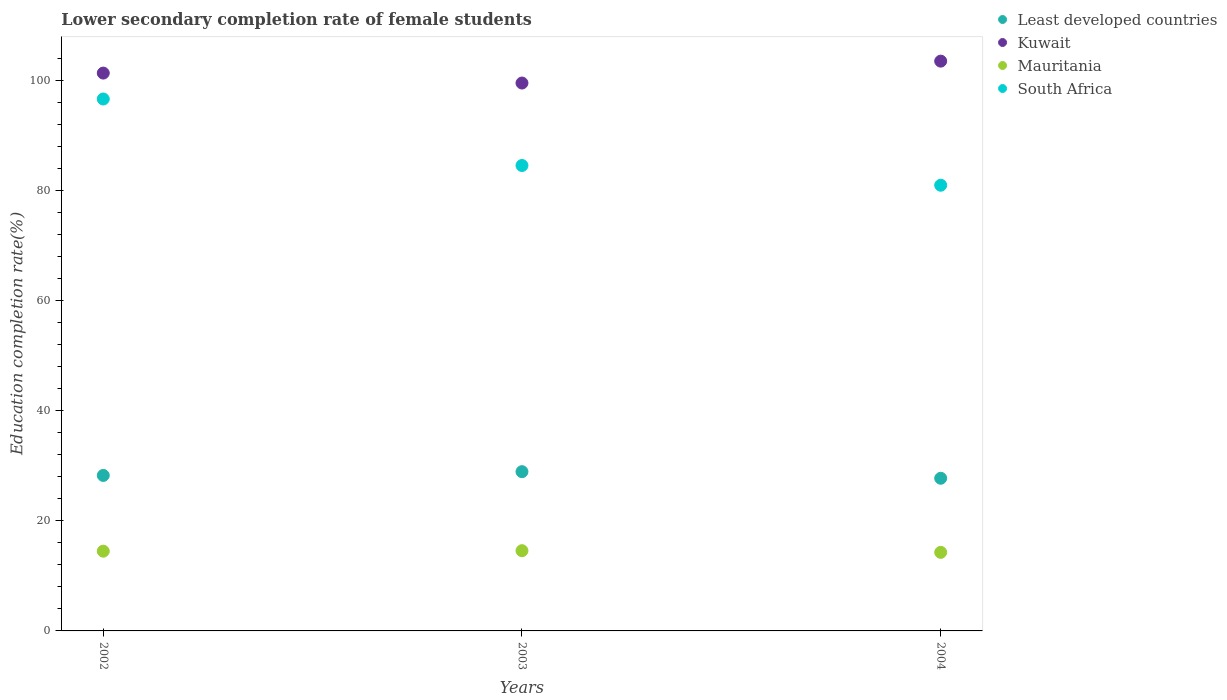How many different coloured dotlines are there?
Keep it short and to the point. 4. Is the number of dotlines equal to the number of legend labels?
Your answer should be very brief. Yes. What is the lower secondary completion rate of female students in South Africa in 2004?
Your answer should be compact. 80.92. Across all years, what is the maximum lower secondary completion rate of female students in South Africa?
Provide a short and direct response. 96.58. Across all years, what is the minimum lower secondary completion rate of female students in Kuwait?
Your response must be concise. 99.48. In which year was the lower secondary completion rate of female students in Least developed countries minimum?
Make the answer very short. 2004. What is the total lower secondary completion rate of female students in South Africa in the graph?
Your answer should be compact. 262. What is the difference between the lower secondary completion rate of female students in Least developed countries in 2002 and that in 2004?
Your answer should be compact. 0.51. What is the difference between the lower secondary completion rate of female students in South Africa in 2004 and the lower secondary completion rate of female students in Least developed countries in 2003?
Provide a succinct answer. 52.01. What is the average lower secondary completion rate of female students in Kuwait per year?
Provide a short and direct response. 101.4. In the year 2002, what is the difference between the lower secondary completion rate of female students in Least developed countries and lower secondary completion rate of female students in Mauritania?
Provide a short and direct response. 13.75. What is the ratio of the lower secondary completion rate of female students in Least developed countries in 2003 to that in 2004?
Your answer should be compact. 1.04. What is the difference between the highest and the second highest lower secondary completion rate of female students in South Africa?
Your answer should be very brief. 12.08. What is the difference between the highest and the lowest lower secondary completion rate of female students in Mauritania?
Your answer should be compact. 0.3. Is the sum of the lower secondary completion rate of female students in Least developed countries in 2002 and 2004 greater than the maximum lower secondary completion rate of female students in Kuwait across all years?
Offer a very short reply. No. Is it the case that in every year, the sum of the lower secondary completion rate of female students in Mauritania and lower secondary completion rate of female students in Kuwait  is greater than the sum of lower secondary completion rate of female students in Least developed countries and lower secondary completion rate of female students in South Africa?
Your answer should be very brief. Yes. Is the lower secondary completion rate of female students in Least developed countries strictly greater than the lower secondary completion rate of female students in South Africa over the years?
Your answer should be very brief. No. Is the lower secondary completion rate of female students in South Africa strictly less than the lower secondary completion rate of female students in Least developed countries over the years?
Make the answer very short. No. How many dotlines are there?
Your answer should be very brief. 4. What is the difference between two consecutive major ticks on the Y-axis?
Your answer should be compact. 20. Does the graph contain grids?
Keep it short and to the point. No. Where does the legend appear in the graph?
Provide a short and direct response. Top right. How many legend labels are there?
Keep it short and to the point. 4. What is the title of the graph?
Offer a terse response. Lower secondary completion rate of female students. What is the label or title of the X-axis?
Your answer should be compact. Years. What is the label or title of the Y-axis?
Provide a succinct answer. Education completion rate(%). What is the Education completion rate(%) in Least developed countries in 2002?
Provide a succinct answer. 28.23. What is the Education completion rate(%) of Kuwait in 2002?
Give a very brief answer. 101.28. What is the Education completion rate(%) of Mauritania in 2002?
Make the answer very short. 14.48. What is the Education completion rate(%) in South Africa in 2002?
Provide a succinct answer. 96.58. What is the Education completion rate(%) in Least developed countries in 2003?
Ensure brevity in your answer.  28.92. What is the Education completion rate(%) of Kuwait in 2003?
Provide a short and direct response. 99.48. What is the Education completion rate(%) of Mauritania in 2003?
Your answer should be very brief. 14.57. What is the Education completion rate(%) of South Africa in 2003?
Your answer should be very brief. 84.5. What is the Education completion rate(%) of Least developed countries in 2004?
Keep it short and to the point. 27.72. What is the Education completion rate(%) of Kuwait in 2004?
Give a very brief answer. 103.45. What is the Education completion rate(%) in Mauritania in 2004?
Your answer should be very brief. 14.26. What is the Education completion rate(%) in South Africa in 2004?
Give a very brief answer. 80.92. Across all years, what is the maximum Education completion rate(%) in Least developed countries?
Keep it short and to the point. 28.92. Across all years, what is the maximum Education completion rate(%) in Kuwait?
Give a very brief answer. 103.45. Across all years, what is the maximum Education completion rate(%) of Mauritania?
Make the answer very short. 14.57. Across all years, what is the maximum Education completion rate(%) of South Africa?
Make the answer very short. 96.58. Across all years, what is the minimum Education completion rate(%) of Least developed countries?
Make the answer very short. 27.72. Across all years, what is the minimum Education completion rate(%) of Kuwait?
Offer a terse response. 99.48. Across all years, what is the minimum Education completion rate(%) of Mauritania?
Offer a terse response. 14.26. Across all years, what is the minimum Education completion rate(%) in South Africa?
Keep it short and to the point. 80.92. What is the total Education completion rate(%) of Least developed countries in the graph?
Ensure brevity in your answer.  84.86. What is the total Education completion rate(%) of Kuwait in the graph?
Your answer should be very brief. 304.21. What is the total Education completion rate(%) of Mauritania in the graph?
Your answer should be very brief. 43.31. What is the total Education completion rate(%) of South Africa in the graph?
Offer a very short reply. 262. What is the difference between the Education completion rate(%) of Least developed countries in 2002 and that in 2003?
Your answer should be compact. -0.68. What is the difference between the Education completion rate(%) of Kuwait in 2002 and that in 2003?
Ensure brevity in your answer.  1.81. What is the difference between the Education completion rate(%) of Mauritania in 2002 and that in 2003?
Make the answer very short. -0.09. What is the difference between the Education completion rate(%) of South Africa in 2002 and that in 2003?
Make the answer very short. 12.08. What is the difference between the Education completion rate(%) of Least developed countries in 2002 and that in 2004?
Ensure brevity in your answer.  0.51. What is the difference between the Education completion rate(%) of Kuwait in 2002 and that in 2004?
Your answer should be very brief. -2.17. What is the difference between the Education completion rate(%) of Mauritania in 2002 and that in 2004?
Your answer should be compact. 0.22. What is the difference between the Education completion rate(%) of South Africa in 2002 and that in 2004?
Keep it short and to the point. 15.66. What is the difference between the Education completion rate(%) of Least developed countries in 2003 and that in 2004?
Your answer should be very brief. 1.2. What is the difference between the Education completion rate(%) in Kuwait in 2003 and that in 2004?
Keep it short and to the point. -3.98. What is the difference between the Education completion rate(%) in Mauritania in 2003 and that in 2004?
Your response must be concise. 0.3. What is the difference between the Education completion rate(%) of South Africa in 2003 and that in 2004?
Offer a very short reply. 3.58. What is the difference between the Education completion rate(%) of Least developed countries in 2002 and the Education completion rate(%) of Kuwait in 2003?
Make the answer very short. -71.24. What is the difference between the Education completion rate(%) of Least developed countries in 2002 and the Education completion rate(%) of Mauritania in 2003?
Offer a very short reply. 13.67. What is the difference between the Education completion rate(%) in Least developed countries in 2002 and the Education completion rate(%) in South Africa in 2003?
Provide a succinct answer. -56.27. What is the difference between the Education completion rate(%) in Kuwait in 2002 and the Education completion rate(%) in Mauritania in 2003?
Offer a very short reply. 86.72. What is the difference between the Education completion rate(%) in Kuwait in 2002 and the Education completion rate(%) in South Africa in 2003?
Provide a succinct answer. 16.78. What is the difference between the Education completion rate(%) of Mauritania in 2002 and the Education completion rate(%) of South Africa in 2003?
Make the answer very short. -70.02. What is the difference between the Education completion rate(%) of Least developed countries in 2002 and the Education completion rate(%) of Kuwait in 2004?
Provide a short and direct response. -75.22. What is the difference between the Education completion rate(%) of Least developed countries in 2002 and the Education completion rate(%) of Mauritania in 2004?
Offer a terse response. 13.97. What is the difference between the Education completion rate(%) of Least developed countries in 2002 and the Education completion rate(%) of South Africa in 2004?
Provide a succinct answer. -52.69. What is the difference between the Education completion rate(%) in Kuwait in 2002 and the Education completion rate(%) in Mauritania in 2004?
Your answer should be very brief. 87.02. What is the difference between the Education completion rate(%) in Kuwait in 2002 and the Education completion rate(%) in South Africa in 2004?
Ensure brevity in your answer.  20.36. What is the difference between the Education completion rate(%) of Mauritania in 2002 and the Education completion rate(%) of South Africa in 2004?
Provide a short and direct response. -66.44. What is the difference between the Education completion rate(%) of Least developed countries in 2003 and the Education completion rate(%) of Kuwait in 2004?
Provide a short and direct response. -74.54. What is the difference between the Education completion rate(%) in Least developed countries in 2003 and the Education completion rate(%) in Mauritania in 2004?
Offer a terse response. 14.65. What is the difference between the Education completion rate(%) of Least developed countries in 2003 and the Education completion rate(%) of South Africa in 2004?
Provide a short and direct response. -52.01. What is the difference between the Education completion rate(%) in Kuwait in 2003 and the Education completion rate(%) in Mauritania in 2004?
Keep it short and to the point. 85.21. What is the difference between the Education completion rate(%) of Kuwait in 2003 and the Education completion rate(%) of South Africa in 2004?
Ensure brevity in your answer.  18.56. What is the difference between the Education completion rate(%) of Mauritania in 2003 and the Education completion rate(%) of South Africa in 2004?
Ensure brevity in your answer.  -66.36. What is the average Education completion rate(%) in Least developed countries per year?
Keep it short and to the point. 28.29. What is the average Education completion rate(%) of Kuwait per year?
Keep it short and to the point. 101.4. What is the average Education completion rate(%) in Mauritania per year?
Keep it short and to the point. 14.44. What is the average Education completion rate(%) in South Africa per year?
Your answer should be compact. 87.33. In the year 2002, what is the difference between the Education completion rate(%) of Least developed countries and Education completion rate(%) of Kuwait?
Ensure brevity in your answer.  -73.05. In the year 2002, what is the difference between the Education completion rate(%) of Least developed countries and Education completion rate(%) of Mauritania?
Offer a terse response. 13.75. In the year 2002, what is the difference between the Education completion rate(%) of Least developed countries and Education completion rate(%) of South Africa?
Keep it short and to the point. -68.35. In the year 2002, what is the difference between the Education completion rate(%) in Kuwait and Education completion rate(%) in Mauritania?
Provide a succinct answer. 86.8. In the year 2002, what is the difference between the Education completion rate(%) in Kuwait and Education completion rate(%) in South Africa?
Provide a succinct answer. 4.7. In the year 2002, what is the difference between the Education completion rate(%) of Mauritania and Education completion rate(%) of South Africa?
Keep it short and to the point. -82.1. In the year 2003, what is the difference between the Education completion rate(%) of Least developed countries and Education completion rate(%) of Kuwait?
Make the answer very short. -70.56. In the year 2003, what is the difference between the Education completion rate(%) of Least developed countries and Education completion rate(%) of Mauritania?
Give a very brief answer. 14.35. In the year 2003, what is the difference between the Education completion rate(%) in Least developed countries and Education completion rate(%) in South Africa?
Your answer should be compact. -55.59. In the year 2003, what is the difference between the Education completion rate(%) in Kuwait and Education completion rate(%) in Mauritania?
Your response must be concise. 84.91. In the year 2003, what is the difference between the Education completion rate(%) of Kuwait and Education completion rate(%) of South Africa?
Ensure brevity in your answer.  14.97. In the year 2003, what is the difference between the Education completion rate(%) in Mauritania and Education completion rate(%) in South Africa?
Make the answer very short. -69.94. In the year 2004, what is the difference between the Education completion rate(%) of Least developed countries and Education completion rate(%) of Kuwait?
Provide a short and direct response. -75.73. In the year 2004, what is the difference between the Education completion rate(%) in Least developed countries and Education completion rate(%) in Mauritania?
Give a very brief answer. 13.45. In the year 2004, what is the difference between the Education completion rate(%) in Least developed countries and Education completion rate(%) in South Africa?
Offer a very short reply. -53.2. In the year 2004, what is the difference between the Education completion rate(%) in Kuwait and Education completion rate(%) in Mauritania?
Your answer should be compact. 89.19. In the year 2004, what is the difference between the Education completion rate(%) of Kuwait and Education completion rate(%) of South Africa?
Your answer should be very brief. 22.53. In the year 2004, what is the difference between the Education completion rate(%) of Mauritania and Education completion rate(%) of South Africa?
Keep it short and to the point. -66.66. What is the ratio of the Education completion rate(%) of Least developed countries in 2002 to that in 2003?
Offer a very short reply. 0.98. What is the ratio of the Education completion rate(%) of Kuwait in 2002 to that in 2003?
Your answer should be very brief. 1.02. What is the ratio of the Education completion rate(%) in Mauritania in 2002 to that in 2003?
Your response must be concise. 0.99. What is the ratio of the Education completion rate(%) in Least developed countries in 2002 to that in 2004?
Offer a very short reply. 1.02. What is the ratio of the Education completion rate(%) in Mauritania in 2002 to that in 2004?
Offer a terse response. 1.02. What is the ratio of the Education completion rate(%) in South Africa in 2002 to that in 2004?
Offer a terse response. 1.19. What is the ratio of the Education completion rate(%) in Least developed countries in 2003 to that in 2004?
Your response must be concise. 1.04. What is the ratio of the Education completion rate(%) of Kuwait in 2003 to that in 2004?
Give a very brief answer. 0.96. What is the ratio of the Education completion rate(%) of Mauritania in 2003 to that in 2004?
Give a very brief answer. 1.02. What is the ratio of the Education completion rate(%) in South Africa in 2003 to that in 2004?
Your response must be concise. 1.04. What is the difference between the highest and the second highest Education completion rate(%) in Least developed countries?
Offer a terse response. 0.68. What is the difference between the highest and the second highest Education completion rate(%) in Kuwait?
Your response must be concise. 2.17. What is the difference between the highest and the second highest Education completion rate(%) in Mauritania?
Provide a short and direct response. 0.09. What is the difference between the highest and the second highest Education completion rate(%) of South Africa?
Offer a very short reply. 12.08. What is the difference between the highest and the lowest Education completion rate(%) of Least developed countries?
Your response must be concise. 1.2. What is the difference between the highest and the lowest Education completion rate(%) in Kuwait?
Provide a short and direct response. 3.98. What is the difference between the highest and the lowest Education completion rate(%) in Mauritania?
Your response must be concise. 0.3. What is the difference between the highest and the lowest Education completion rate(%) of South Africa?
Offer a terse response. 15.66. 